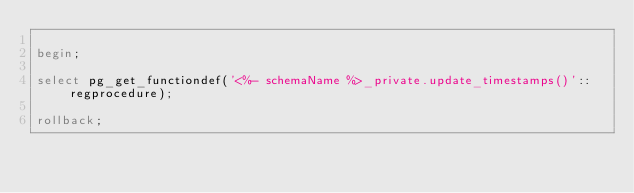Convert code to text. <code><loc_0><loc_0><loc_500><loc_500><_SQL_>
begin;

select pg_get_functiondef('<%- schemaName %>_private.update_timestamps()'::regprocedure);

rollback;
</code> 